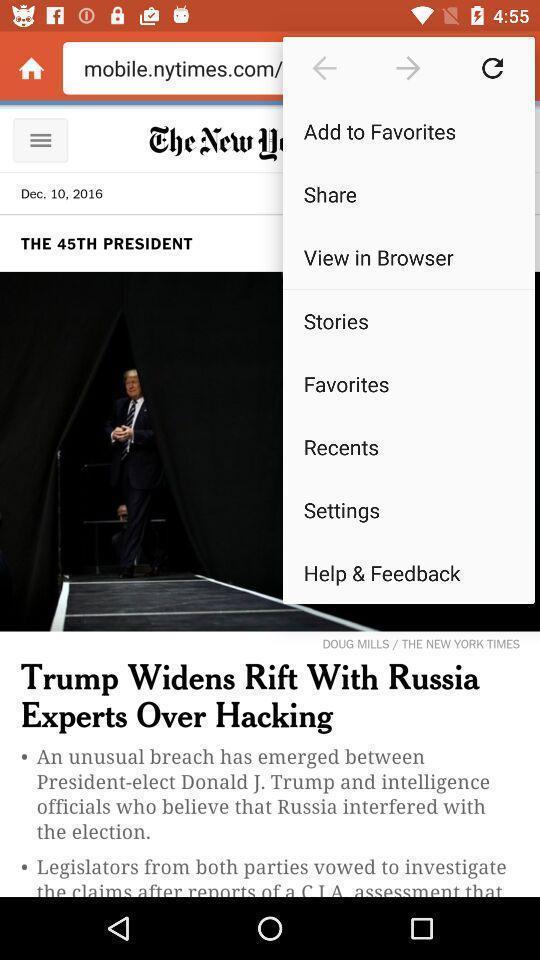Provide a detailed account of this screenshot. Pop-up showing list of options for a website. 